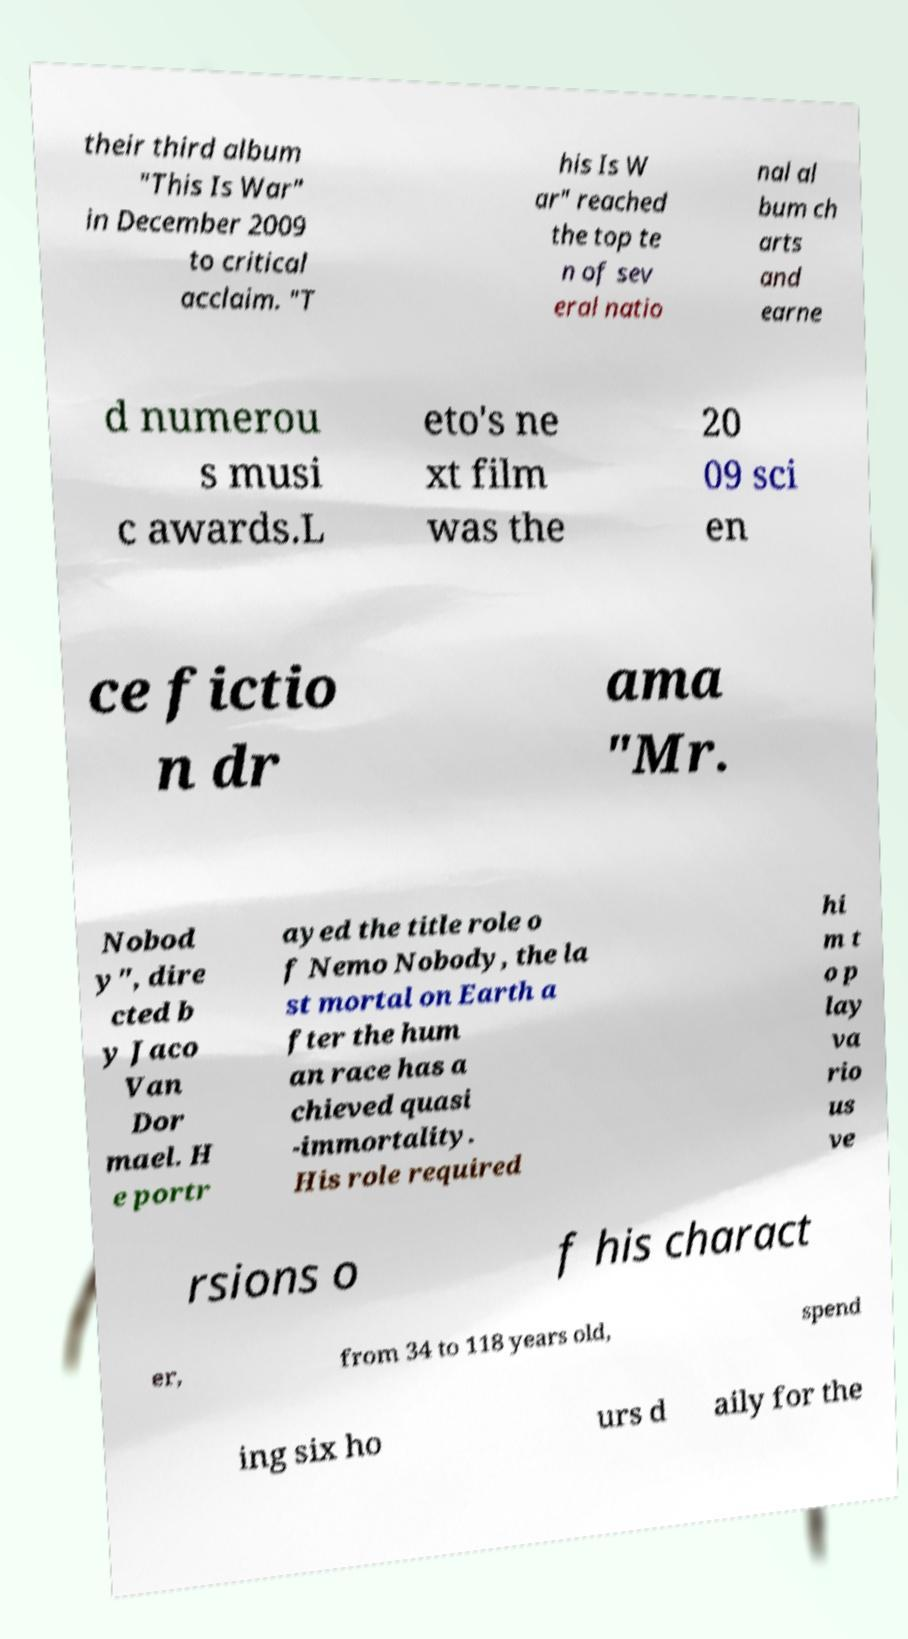Could you extract and type out the text from this image? their third album "This Is War" in December 2009 to critical acclaim. "T his Is W ar" reached the top te n of sev eral natio nal al bum ch arts and earne d numerou s musi c awards.L eto's ne xt film was the 20 09 sci en ce fictio n dr ama "Mr. Nobod y", dire cted b y Jaco Van Dor mael. H e portr ayed the title role o f Nemo Nobody, the la st mortal on Earth a fter the hum an race has a chieved quasi -immortality. His role required hi m t o p lay va rio us ve rsions o f his charact er, from 34 to 118 years old, spend ing six ho urs d aily for the 